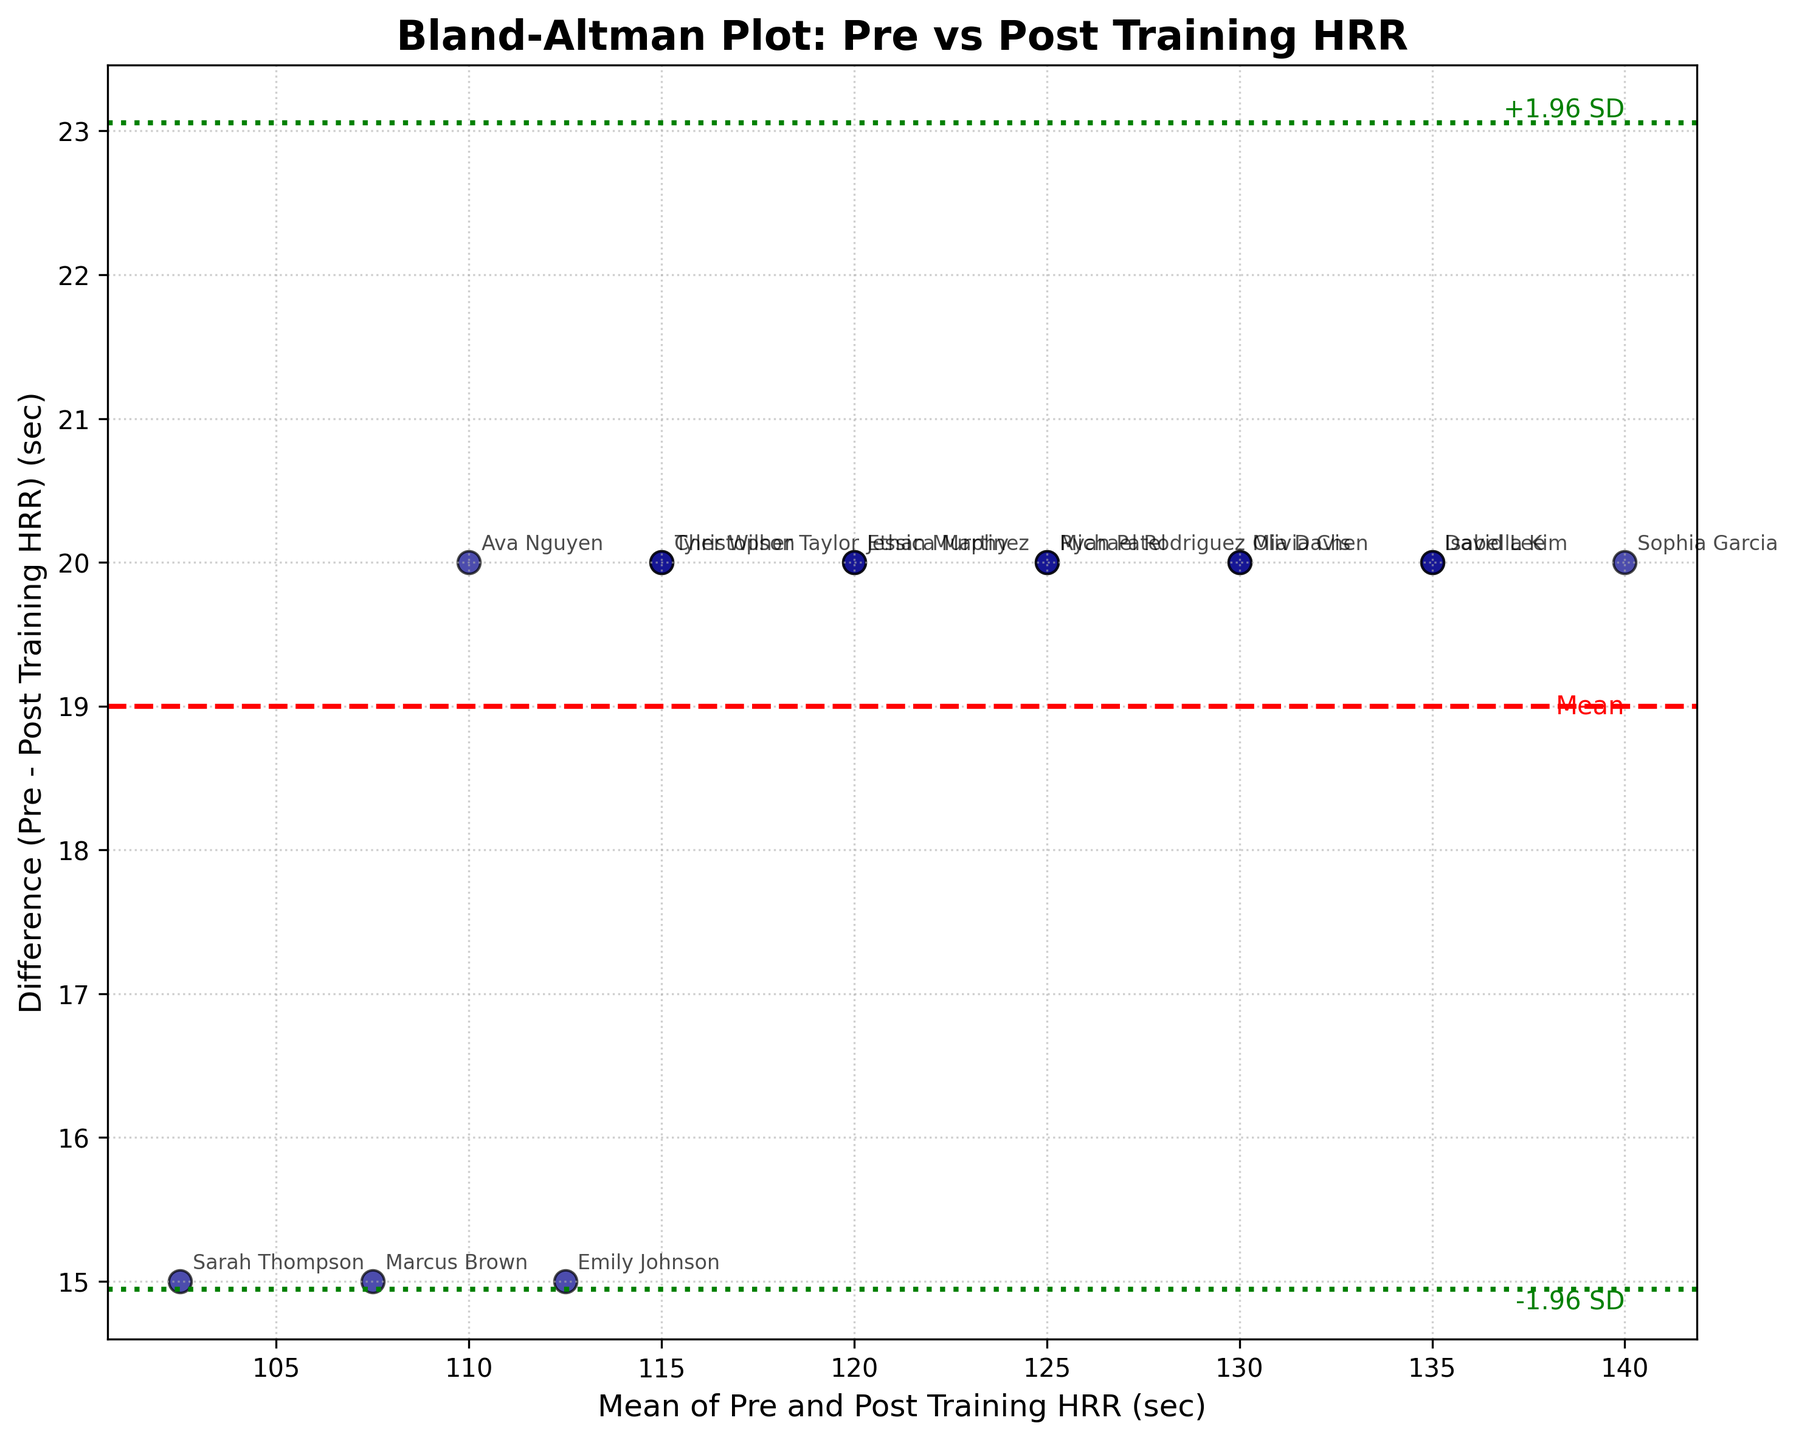What's the title of the plot? The title is usually situated at the top of the figure, and in this case, it reads "Bland-Altman Plot: Pre vs Post Training HRR."
Answer: Bland-Altman Plot: Pre vs Post Training HRR How many data points are plotted? You can count each player's represented point on the scatterplot. Each player is represented by one point, and there are 15 points on the graph.
Answer: 15 What's the mean difference between pre and post-training HRR? The mean difference is represented by the red dashed line that intersects the y-axis.
Answer: It is the value at the red dashed line What are the +1.96 SD and -1.96 SD limits? These limits are represented by the green dotted lines above and below the red dashed line. You can find the y-values of these lines to get the limits.
Answer: The y-values of the green dotted lines above and below the red dashed line Which player has the largest positive difference between pre and post-training HRR? Look for the point that has the highest y-value, indicating the largest positive difference. The point label next to it is the player's name.
Answer: It is the player with the highest point on the y-axis How much did Sarah Thompson's HRR improve after training? Find Sarah Thompson's data point on the plot and measure the difference on the y-axis. If the difference is positive, that value represents the HRR improvement.
Answer: It is the y-value of Sarah Thompson's point if it's positive What is the trend indicated by the figure? Observe the placement of the data points and the lines. If most points lie below the mean difference line, it suggests that HRR improved post-training.
Answer: It indicates an overall improvement in HRR post-training Are there any outliers? Look for points that lie far away from the mean difference line and outside the +1.96 SD and -1.96 SD lines. These would be considered outliers.
Answer: Points outside the green dotted lines Which player has the smallest mean of pre and post-training HRR? Calculate the mean of pre and post-training HRR for each player and identify the smallest mean.
Answer: It is the player with the lowest mean on the x-axis How do the majority of data points spread relative to the zero difference line? Assess if more data points are clustered above or below the zero difference line, indicating a certain trend.
Answer: Most data points are likely below the zero difference line 